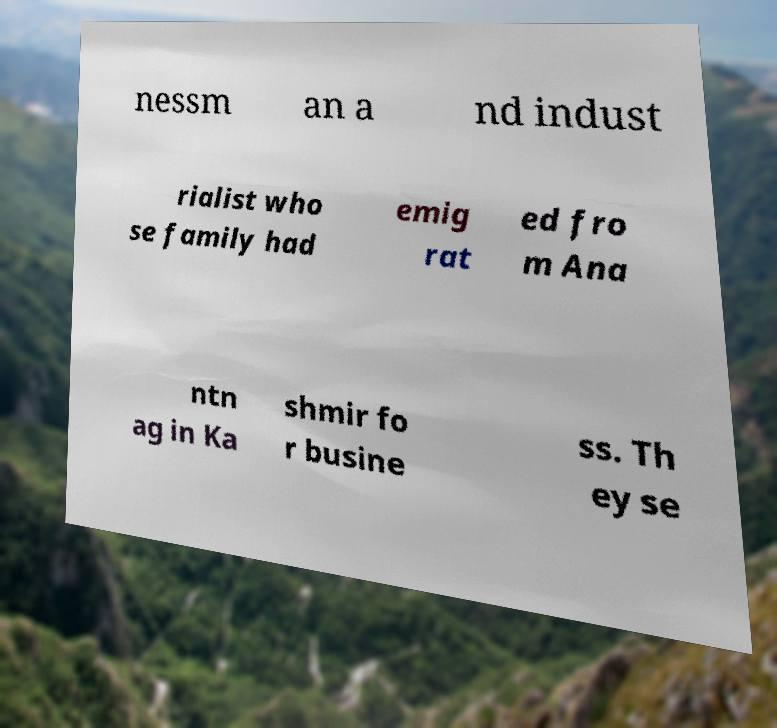Could you extract and type out the text from this image? nessm an a nd indust rialist who se family had emig rat ed fro m Ana ntn ag in Ka shmir fo r busine ss. Th ey se 